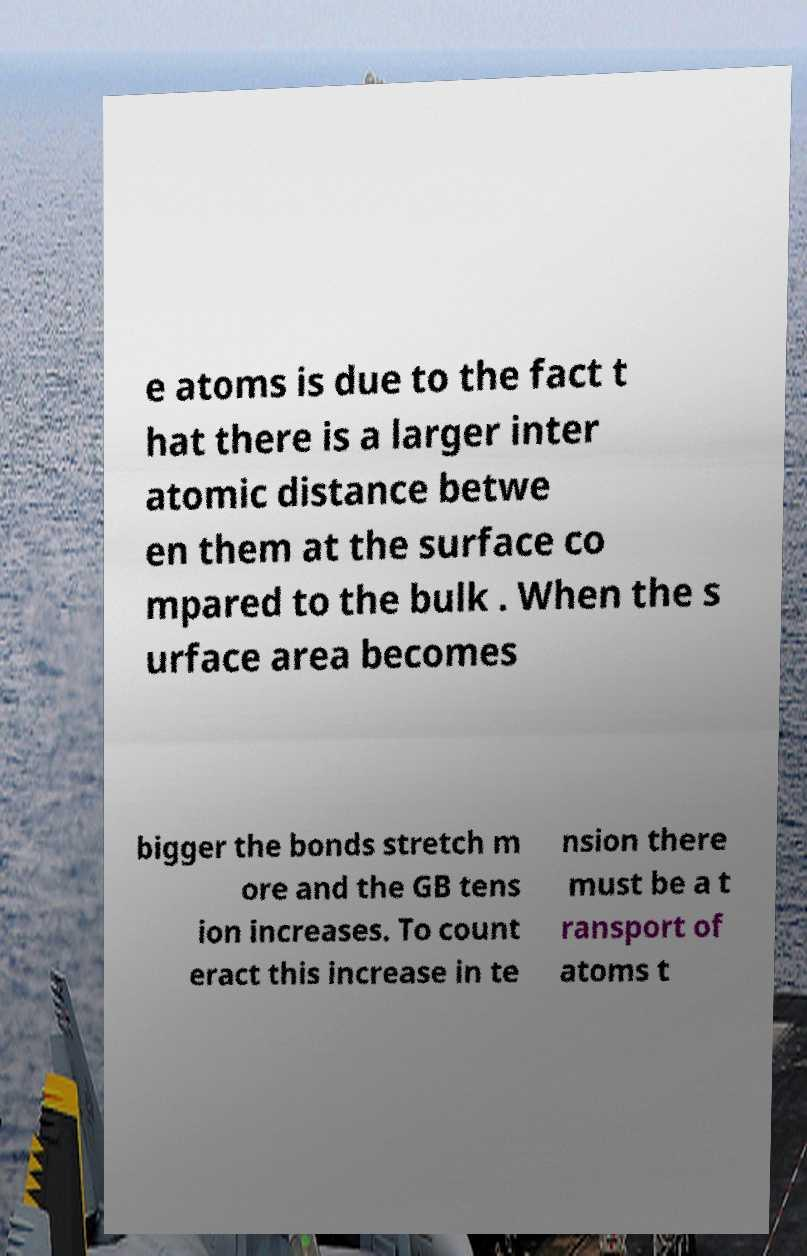Could you extract and type out the text from this image? e atoms is due to the fact t hat there is a larger inter atomic distance betwe en them at the surface co mpared to the bulk . When the s urface area becomes bigger the bonds stretch m ore and the GB tens ion increases. To count eract this increase in te nsion there must be a t ransport of atoms t 